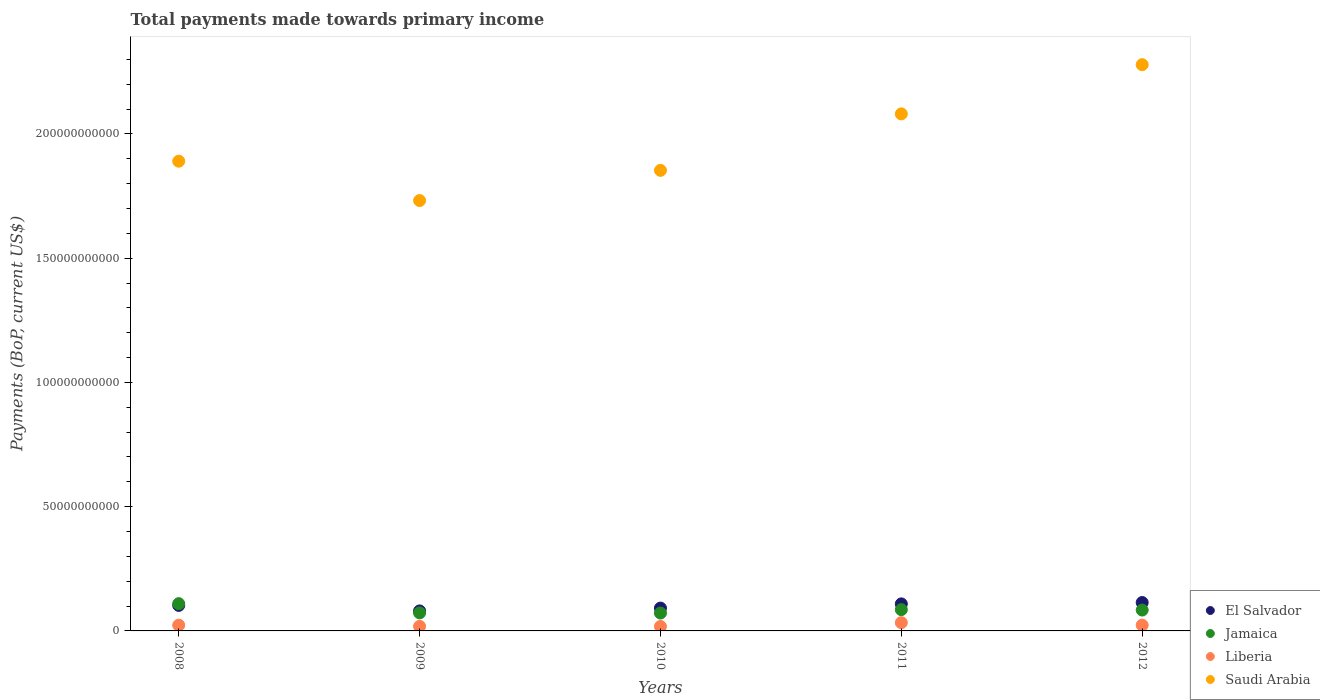What is the total payments made towards primary income in Liberia in 2008?
Ensure brevity in your answer.  2.31e+09. Across all years, what is the maximum total payments made towards primary income in Liberia?
Offer a terse response. 3.33e+09. Across all years, what is the minimum total payments made towards primary income in Saudi Arabia?
Offer a terse response. 1.73e+11. In which year was the total payments made towards primary income in Liberia maximum?
Ensure brevity in your answer.  2011. In which year was the total payments made towards primary income in Jamaica minimum?
Offer a terse response. 2010. What is the total total payments made towards primary income in Saudi Arabia in the graph?
Your response must be concise. 9.83e+11. What is the difference between the total payments made towards primary income in Liberia in 2010 and that in 2011?
Provide a short and direct response. -1.52e+09. What is the difference between the total payments made towards primary income in Jamaica in 2008 and the total payments made towards primary income in El Salvador in 2012?
Provide a short and direct response. -4.55e+08. What is the average total payments made towards primary income in Saudi Arabia per year?
Provide a short and direct response. 1.97e+11. In the year 2009, what is the difference between the total payments made towards primary income in Saudi Arabia and total payments made towards primary income in Liberia?
Give a very brief answer. 1.71e+11. In how many years, is the total payments made towards primary income in Liberia greater than 90000000000 US$?
Keep it short and to the point. 0. What is the ratio of the total payments made towards primary income in Saudi Arabia in 2009 to that in 2010?
Provide a short and direct response. 0.93. Is the difference between the total payments made towards primary income in Saudi Arabia in 2008 and 2010 greater than the difference between the total payments made towards primary income in Liberia in 2008 and 2010?
Your answer should be very brief. Yes. What is the difference between the highest and the second highest total payments made towards primary income in Saudi Arabia?
Provide a short and direct response. 1.98e+1. What is the difference between the highest and the lowest total payments made towards primary income in El Salvador?
Your answer should be very brief. 3.38e+09. Is it the case that in every year, the sum of the total payments made towards primary income in Liberia and total payments made towards primary income in El Salvador  is greater than the total payments made towards primary income in Jamaica?
Ensure brevity in your answer.  Yes. Is the total payments made towards primary income in Liberia strictly greater than the total payments made towards primary income in Jamaica over the years?
Your response must be concise. No. What is the difference between two consecutive major ticks on the Y-axis?
Ensure brevity in your answer.  5.00e+1. Are the values on the major ticks of Y-axis written in scientific E-notation?
Your response must be concise. No. How are the legend labels stacked?
Offer a very short reply. Vertical. What is the title of the graph?
Ensure brevity in your answer.  Total payments made towards primary income. Does "Congo (Republic)" appear as one of the legend labels in the graph?
Give a very brief answer. No. What is the label or title of the Y-axis?
Your answer should be very brief. Payments (BoP, current US$). What is the Payments (BoP, current US$) of El Salvador in 2008?
Offer a very short reply. 1.03e+1. What is the Payments (BoP, current US$) of Jamaica in 2008?
Provide a short and direct response. 1.10e+1. What is the Payments (BoP, current US$) of Liberia in 2008?
Give a very brief answer. 2.31e+09. What is the Payments (BoP, current US$) in Saudi Arabia in 2008?
Provide a succinct answer. 1.89e+11. What is the Payments (BoP, current US$) of El Salvador in 2009?
Provide a short and direct response. 8.05e+09. What is the Payments (BoP, current US$) of Jamaica in 2009?
Provide a succinct answer. 7.26e+09. What is the Payments (BoP, current US$) in Liberia in 2009?
Keep it short and to the point. 1.85e+09. What is the Payments (BoP, current US$) of Saudi Arabia in 2009?
Provide a short and direct response. 1.73e+11. What is the Payments (BoP, current US$) in El Salvador in 2010?
Make the answer very short. 9.19e+09. What is the Payments (BoP, current US$) in Jamaica in 2010?
Make the answer very short. 7.19e+09. What is the Payments (BoP, current US$) of Liberia in 2010?
Offer a terse response. 1.80e+09. What is the Payments (BoP, current US$) of Saudi Arabia in 2010?
Make the answer very short. 1.85e+11. What is the Payments (BoP, current US$) of El Salvador in 2011?
Your response must be concise. 1.09e+1. What is the Payments (BoP, current US$) of Jamaica in 2011?
Ensure brevity in your answer.  8.57e+09. What is the Payments (BoP, current US$) of Liberia in 2011?
Your response must be concise. 3.33e+09. What is the Payments (BoP, current US$) of Saudi Arabia in 2011?
Offer a terse response. 2.08e+11. What is the Payments (BoP, current US$) in El Salvador in 2012?
Your answer should be very brief. 1.14e+1. What is the Payments (BoP, current US$) of Jamaica in 2012?
Offer a very short reply. 8.40e+09. What is the Payments (BoP, current US$) in Liberia in 2012?
Offer a very short reply. 2.32e+09. What is the Payments (BoP, current US$) in Saudi Arabia in 2012?
Provide a short and direct response. 2.28e+11. Across all years, what is the maximum Payments (BoP, current US$) of El Salvador?
Your response must be concise. 1.14e+1. Across all years, what is the maximum Payments (BoP, current US$) in Jamaica?
Your answer should be compact. 1.10e+1. Across all years, what is the maximum Payments (BoP, current US$) of Liberia?
Provide a succinct answer. 3.33e+09. Across all years, what is the maximum Payments (BoP, current US$) of Saudi Arabia?
Make the answer very short. 2.28e+11. Across all years, what is the minimum Payments (BoP, current US$) in El Salvador?
Make the answer very short. 8.05e+09. Across all years, what is the minimum Payments (BoP, current US$) in Jamaica?
Make the answer very short. 7.19e+09. Across all years, what is the minimum Payments (BoP, current US$) in Liberia?
Your response must be concise. 1.80e+09. Across all years, what is the minimum Payments (BoP, current US$) of Saudi Arabia?
Offer a very short reply. 1.73e+11. What is the total Payments (BoP, current US$) in El Salvador in the graph?
Provide a short and direct response. 4.98e+1. What is the total Payments (BoP, current US$) in Jamaica in the graph?
Keep it short and to the point. 4.24e+1. What is the total Payments (BoP, current US$) in Liberia in the graph?
Provide a succinct answer. 1.16e+1. What is the total Payments (BoP, current US$) of Saudi Arabia in the graph?
Provide a short and direct response. 9.83e+11. What is the difference between the Payments (BoP, current US$) in El Salvador in 2008 and that in 2009?
Offer a very short reply. 2.22e+09. What is the difference between the Payments (BoP, current US$) in Jamaica in 2008 and that in 2009?
Keep it short and to the point. 3.71e+09. What is the difference between the Payments (BoP, current US$) in Liberia in 2008 and that in 2009?
Keep it short and to the point. 4.61e+08. What is the difference between the Payments (BoP, current US$) in Saudi Arabia in 2008 and that in 2009?
Offer a very short reply. 1.58e+1. What is the difference between the Payments (BoP, current US$) in El Salvador in 2008 and that in 2010?
Your answer should be very brief. 1.08e+09. What is the difference between the Payments (BoP, current US$) of Jamaica in 2008 and that in 2010?
Make the answer very short. 3.78e+09. What is the difference between the Payments (BoP, current US$) of Liberia in 2008 and that in 2010?
Provide a short and direct response. 5.06e+08. What is the difference between the Payments (BoP, current US$) of Saudi Arabia in 2008 and that in 2010?
Your answer should be compact. 3.69e+09. What is the difference between the Payments (BoP, current US$) in El Salvador in 2008 and that in 2011?
Give a very brief answer. -6.14e+08. What is the difference between the Payments (BoP, current US$) of Jamaica in 2008 and that in 2011?
Offer a terse response. 2.40e+09. What is the difference between the Payments (BoP, current US$) of Liberia in 2008 and that in 2011?
Your answer should be very brief. -1.01e+09. What is the difference between the Payments (BoP, current US$) in Saudi Arabia in 2008 and that in 2011?
Provide a short and direct response. -1.90e+1. What is the difference between the Payments (BoP, current US$) in El Salvador in 2008 and that in 2012?
Ensure brevity in your answer.  -1.16e+09. What is the difference between the Payments (BoP, current US$) in Jamaica in 2008 and that in 2012?
Ensure brevity in your answer.  2.57e+09. What is the difference between the Payments (BoP, current US$) in Liberia in 2008 and that in 2012?
Provide a short and direct response. -6.47e+06. What is the difference between the Payments (BoP, current US$) in Saudi Arabia in 2008 and that in 2012?
Make the answer very short. -3.88e+1. What is the difference between the Payments (BoP, current US$) of El Salvador in 2009 and that in 2010?
Your answer should be compact. -1.14e+09. What is the difference between the Payments (BoP, current US$) in Jamaica in 2009 and that in 2010?
Give a very brief answer. 6.76e+07. What is the difference between the Payments (BoP, current US$) in Liberia in 2009 and that in 2010?
Ensure brevity in your answer.  4.54e+07. What is the difference between the Payments (BoP, current US$) in Saudi Arabia in 2009 and that in 2010?
Provide a short and direct response. -1.21e+1. What is the difference between the Payments (BoP, current US$) in El Salvador in 2009 and that in 2011?
Give a very brief answer. -2.83e+09. What is the difference between the Payments (BoP, current US$) of Jamaica in 2009 and that in 2011?
Your answer should be compact. -1.31e+09. What is the difference between the Payments (BoP, current US$) of Liberia in 2009 and that in 2011?
Your answer should be very brief. -1.48e+09. What is the difference between the Payments (BoP, current US$) of Saudi Arabia in 2009 and that in 2011?
Your answer should be compact. -3.49e+1. What is the difference between the Payments (BoP, current US$) of El Salvador in 2009 and that in 2012?
Offer a very short reply. -3.38e+09. What is the difference between the Payments (BoP, current US$) in Jamaica in 2009 and that in 2012?
Make the answer very short. -1.14e+09. What is the difference between the Payments (BoP, current US$) in Liberia in 2009 and that in 2012?
Provide a succinct answer. -4.67e+08. What is the difference between the Payments (BoP, current US$) of Saudi Arabia in 2009 and that in 2012?
Offer a very short reply. -5.47e+1. What is the difference between the Payments (BoP, current US$) in El Salvador in 2010 and that in 2011?
Ensure brevity in your answer.  -1.69e+09. What is the difference between the Payments (BoP, current US$) in Jamaica in 2010 and that in 2011?
Your answer should be compact. -1.38e+09. What is the difference between the Payments (BoP, current US$) of Liberia in 2010 and that in 2011?
Make the answer very short. -1.52e+09. What is the difference between the Payments (BoP, current US$) in Saudi Arabia in 2010 and that in 2011?
Give a very brief answer. -2.27e+1. What is the difference between the Payments (BoP, current US$) in El Salvador in 2010 and that in 2012?
Provide a succinct answer. -2.24e+09. What is the difference between the Payments (BoP, current US$) in Jamaica in 2010 and that in 2012?
Ensure brevity in your answer.  -1.20e+09. What is the difference between the Payments (BoP, current US$) in Liberia in 2010 and that in 2012?
Offer a terse response. -5.12e+08. What is the difference between the Payments (BoP, current US$) of Saudi Arabia in 2010 and that in 2012?
Offer a terse response. -4.25e+1. What is the difference between the Payments (BoP, current US$) of El Salvador in 2011 and that in 2012?
Keep it short and to the point. -5.44e+08. What is the difference between the Payments (BoP, current US$) of Jamaica in 2011 and that in 2012?
Your answer should be compact. 1.71e+08. What is the difference between the Payments (BoP, current US$) in Liberia in 2011 and that in 2012?
Give a very brief answer. 1.01e+09. What is the difference between the Payments (BoP, current US$) in Saudi Arabia in 2011 and that in 2012?
Make the answer very short. -1.98e+1. What is the difference between the Payments (BoP, current US$) of El Salvador in 2008 and the Payments (BoP, current US$) of Jamaica in 2009?
Your answer should be compact. 3.01e+09. What is the difference between the Payments (BoP, current US$) of El Salvador in 2008 and the Payments (BoP, current US$) of Liberia in 2009?
Offer a very short reply. 8.42e+09. What is the difference between the Payments (BoP, current US$) of El Salvador in 2008 and the Payments (BoP, current US$) of Saudi Arabia in 2009?
Your answer should be compact. -1.63e+11. What is the difference between the Payments (BoP, current US$) in Jamaica in 2008 and the Payments (BoP, current US$) in Liberia in 2009?
Offer a terse response. 9.12e+09. What is the difference between the Payments (BoP, current US$) in Jamaica in 2008 and the Payments (BoP, current US$) in Saudi Arabia in 2009?
Provide a succinct answer. -1.62e+11. What is the difference between the Payments (BoP, current US$) in Liberia in 2008 and the Payments (BoP, current US$) in Saudi Arabia in 2009?
Provide a short and direct response. -1.71e+11. What is the difference between the Payments (BoP, current US$) in El Salvador in 2008 and the Payments (BoP, current US$) in Jamaica in 2010?
Provide a short and direct response. 3.08e+09. What is the difference between the Payments (BoP, current US$) of El Salvador in 2008 and the Payments (BoP, current US$) of Liberia in 2010?
Offer a very short reply. 8.46e+09. What is the difference between the Payments (BoP, current US$) of El Salvador in 2008 and the Payments (BoP, current US$) of Saudi Arabia in 2010?
Keep it short and to the point. -1.75e+11. What is the difference between the Payments (BoP, current US$) of Jamaica in 2008 and the Payments (BoP, current US$) of Liberia in 2010?
Offer a terse response. 9.17e+09. What is the difference between the Payments (BoP, current US$) of Jamaica in 2008 and the Payments (BoP, current US$) of Saudi Arabia in 2010?
Your answer should be compact. -1.74e+11. What is the difference between the Payments (BoP, current US$) of Liberia in 2008 and the Payments (BoP, current US$) of Saudi Arabia in 2010?
Provide a succinct answer. -1.83e+11. What is the difference between the Payments (BoP, current US$) in El Salvador in 2008 and the Payments (BoP, current US$) in Jamaica in 2011?
Offer a very short reply. 1.70e+09. What is the difference between the Payments (BoP, current US$) in El Salvador in 2008 and the Payments (BoP, current US$) in Liberia in 2011?
Your response must be concise. 6.94e+09. What is the difference between the Payments (BoP, current US$) of El Salvador in 2008 and the Payments (BoP, current US$) of Saudi Arabia in 2011?
Keep it short and to the point. -1.98e+11. What is the difference between the Payments (BoP, current US$) of Jamaica in 2008 and the Payments (BoP, current US$) of Liberia in 2011?
Keep it short and to the point. 7.64e+09. What is the difference between the Payments (BoP, current US$) of Jamaica in 2008 and the Payments (BoP, current US$) of Saudi Arabia in 2011?
Ensure brevity in your answer.  -1.97e+11. What is the difference between the Payments (BoP, current US$) of Liberia in 2008 and the Payments (BoP, current US$) of Saudi Arabia in 2011?
Make the answer very short. -2.06e+11. What is the difference between the Payments (BoP, current US$) of El Salvador in 2008 and the Payments (BoP, current US$) of Jamaica in 2012?
Provide a succinct answer. 1.87e+09. What is the difference between the Payments (BoP, current US$) of El Salvador in 2008 and the Payments (BoP, current US$) of Liberia in 2012?
Make the answer very short. 7.95e+09. What is the difference between the Payments (BoP, current US$) in El Salvador in 2008 and the Payments (BoP, current US$) in Saudi Arabia in 2012?
Offer a very short reply. -2.18e+11. What is the difference between the Payments (BoP, current US$) in Jamaica in 2008 and the Payments (BoP, current US$) in Liberia in 2012?
Make the answer very short. 8.65e+09. What is the difference between the Payments (BoP, current US$) in Jamaica in 2008 and the Payments (BoP, current US$) in Saudi Arabia in 2012?
Provide a succinct answer. -2.17e+11. What is the difference between the Payments (BoP, current US$) in Liberia in 2008 and the Payments (BoP, current US$) in Saudi Arabia in 2012?
Offer a very short reply. -2.26e+11. What is the difference between the Payments (BoP, current US$) of El Salvador in 2009 and the Payments (BoP, current US$) of Jamaica in 2010?
Offer a terse response. 8.55e+08. What is the difference between the Payments (BoP, current US$) of El Salvador in 2009 and the Payments (BoP, current US$) of Liberia in 2010?
Ensure brevity in your answer.  6.24e+09. What is the difference between the Payments (BoP, current US$) in El Salvador in 2009 and the Payments (BoP, current US$) in Saudi Arabia in 2010?
Make the answer very short. -1.77e+11. What is the difference between the Payments (BoP, current US$) in Jamaica in 2009 and the Payments (BoP, current US$) in Liberia in 2010?
Your response must be concise. 5.45e+09. What is the difference between the Payments (BoP, current US$) of Jamaica in 2009 and the Payments (BoP, current US$) of Saudi Arabia in 2010?
Offer a very short reply. -1.78e+11. What is the difference between the Payments (BoP, current US$) of Liberia in 2009 and the Payments (BoP, current US$) of Saudi Arabia in 2010?
Offer a terse response. -1.83e+11. What is the difference between the Payments (BoP, current US$) in El Salvador in 2009 and the Payments (BoP, current US$) in Jamaica in 2011?
Your answer should be compact. -5.21e+08. What is the difference between the Payments (BoP, current US$) of El Salvador in 2009 and the Payments (BoP, current US$) of Liberia in 2011?
Provide a succinct answer. 4.72e+09. What is the difference between the Payments (BoP, current US$) in El Salvador in 2009 and the Payments (BoP, current US$) in Saudi Arabia in 2011?
Make the answer very short. -2.00e+11. What is the difference between the Payments (BoP, current US$) of Jamaica in 2009 and the Payments (BoP, current US$) of Liberia in 2011?
Your answer should be very brief. 3.93e+09. What is the difference between the Payments (BoP, current US$) in Jamaica in 2009 and the Payments (BoP, current US$) in Saudi Arabia in 2011?
Your answer should be compact. -2.01e+11. What is the difference between the Payments (BoP, current US$) in Liberia in 2009 and the Payments (BoP, current US$) in Saudi Arabia in 2011?
Keep it short and to the point. -2.06e+11. What is the difference between the Payments (BoP, current US$) in El Salvador in 2009 and the Payments (BoP, current US$) in Jamaica in 2012?
Your answer should be compact. -3.49e+08. What is the difference between the Payments (BoP, current US$) in El Salvador in 2009 and the Payments (BoP, current US$) in Liberia in 2012?
Your response must be concise. 5.73e+09. What is the difference between the Payments (BoP, current US$) of El Salvador in 2009 and the Payments (BoP, current US$) of Saudi Arabia in 2012?
Provide a succinct answer. -2.20e+11. What is the difference between the Payments (BoP, current US$) of Jamaica in 2009 and the Payments (BoP, current US$) of Liberia in 2012?
Keep it short and to the point. 4.94e+09. What is the difference between the Payments (BoP, current US$) of Jamaica in 2009 and the Payments (BoP, current US$) of Saudi Arabia in 2012?
Keep it short and to the point. -2.21e+11. What is the difference between the Payments (BoP, current US$) in Liberia in 2009 and the Payments (BoP, current US$) in Saudi Arabia in 2012?
Your response must be concise. -2.26e+11. What is the difference between the Payments (BoP, current US$) in El Salvador in 2010 and the Payments (BoP, current US$) in Jamaica in 2011?
Your answer should be compact. 6.22e+08. What is the difference between the Payments (BoP, current US$) in El Salvador in 2010 and the Payments (BoP, current US$) in Liberia in 2011?
Your answer should be compact. 5.86e+09. What is the difference between the Payments (BoP, current US$) in El Salvador in 2010 and the Payments (BoP, current US$) in Saudi Arabia in 2011?
Offer a very short reply. -1.99e+11. What is the difference between the Payments (BoP, current US$) of Jamaica in 2010 and the Payments (BoP, current US$) of Liberia in 2011?
Your answer should be very brief. 3.87e+09. What is the difference between the Payments (BoP, current US$) of Jamaica in 2010 and the Payments (BoP, current US$) of Saudi Arabia in 2011?
Give a very brief answer. -2.01e+11. What is the difference between the Payments (BoP, current US$) in Liberia in 2010 and the Payments (BoP, current US$) in Saudi Arabia in 2011?
Offer a very short reply. -2.06e+11. What is the difference between the Payments (BoP, current US$) in El Salvador in 2010 and the Payments (BoP, current US$) in Jamaica in 2012?
Your answer should be very brief. 7.94e+08. What is the difference between the Payments (BoP, current US$) in El Salvador in 2010 and the Payments (BoP, current US$) in Liberia in 2012?
Make the answer very short. 6.87e+09. What is the difference between the Payments (BoP, current US$) in El Salvador in 2010 and the Payments (BoP, current US$) in Saudi Arabia in 2012?
Provide a short and direct response. -2.19e+11. What is the difference between the Payments (BoP, current US$) in Jamaica in 2010 and the Payments (BoP, current US$) in Liberia in 2012?
Offer a very short reply. 4.87e+09. What is the difference between the Payments (BoP, current US$) of Jamaica in 2010 and the Payments (BoP, current US$) of Saudi Arabia in 2012?
Make the answer very short. -2.21e+11. What is the difference between the Payments (BoP, current US$) in Liberia in 2010 and the Payments (BoP, current US$) in Saudi Arabia in 2012?
Make the answer very short. -2.26e+11. What is the difference between the Payments (BoP, current US$) in El Salvador in 2011 and the Payments (BoP, current US$) in Jamaica in 2012?
Your answer should be compact. 2.49e+09. What is the difference between the Payments (BoP, current US$) of El Salvador in 2011 and the Payments (BoP, current US$) of Liberia in 2012?
Ensure brevity in your answer.  8.56e+09. What is the difference between the Payments (BoP, current US$) in El Salvador in 2011 and the Payments (BoP, current US$) in Saudi Arabia in 2012?
Offer a very short reply. -2.17e+11. What is the difference between the Payments (BoP, current US$) in Jamaica in 2011 and the Payments (BoP, current US$) in Liberia in 2012?
Keep it short and to the point. 6.25e+09. What is the difference between the Payments (BoP, current US$) of Jamaica in 2011 and the Payments (BoP, current US$) of Saudi Arabia in 2012?
Provide a short and direct response. -2.19e+11. What is the difference between the Payments (BoP, current US$) in Liberia in 2011 and the Payments (BoP, current US$) in Saudi Arabia in 2012?
Provide a short and direct response. -2.25e+11. What is the average Payments (BoP, current US$) of El Salvador per year?
Your answer should be very brief. 9.96e+09. What is the average Payments (BoP, current US$) in Jamaica per year?
Ensure brevity in your answer.  8.48e+09. What is the average Payments (BoP, current US$) in Liberia per year?
Give a very brief answer. 2.32e+09. What is the average Payments (BoP, current US$) in Saudi Arabia per year?
Offer a terse response. 1.97e+11. In the year 2008, what is the difference between the Payments (BoP, current US$) of El Salvador and Payments (BoP, current US$) of Jamaica?
Offer a terse response. -7.02e+08. In the year 2008, what is the difference between the Payments (BoP, current US$) in El Salvador and Payments (BoP, current US$) in Liberia?
Your answer should be very brief. 7.96e+09. In the year 2008, what is the difference between the Payments (BoP, current US$) in El Salvador and Payments (BoP, current US$) in Saudi Arabia?
Your answer should be very brief. -1.79e+11. In the year 2008, what is the difference between the Payments (BoP, current US$) in Jamaica and Payments (BoP, current US$) in Liberia?
Your response must be concise. 8.66e+09. In the year 2008, what is the difference between the Payments (BoP, current US$) of Jamaica and Payments (BoP, current US$) of Saudi Arabia?
Provide a short and direct response. -1.78e+11. In the year 2008, what is the difference between the Payments (BoP, current US$) in Liberia and Payments (BoP, current US$) in Saudi Arabia?
Provide a short and direct response. -1.87e+11. In the year 2009, what is the difference between the Payments (BoP, current US$) in El Salvador and Payments (BoP, current US$) in Jamaica?
Make the answer very short. 7.88e+08. In the year 2009, what is the difference between the Payments (BoP, current US$) in El Salvador and Payments (BoP, current US$) in Liberia?
Your response must be concise. 6.20e+09. In the year 2009, what is the difference between the Payments (BoP, current US$) of El Salvador and Payments (BoP, current US$) of Saudi Arabia?
Your response must be concise. -1.65e+11. In the year 2009, what is the difference between the Payments (BoP, current US$) in Jamaica and Payments (BoP, current US$) in Liberia?
Give a very brief answer. 5.41e+09. In the year 2009, what is the difference between the Payments (BoP, current US$) in Jamaica and Payments (BoP, current US$) in Saudi Arabia?
Make the answer very short. -1.66e+11. In the year 2009, what is the difference between the Payments (BoP, current US$) in Liberia and Payments (BoP, current US$) in Saudi Arabia?
Your response must be concise. -1.71e+11. In the year 2010, what is the difference between the Payments (BoP, current US$) in El Salvador and Payments (BoP, current US$) in Jamaica?
Provide a short and direct response. 2.00e+09. In the year 2010, what is the difference between the Payments (BoP, current US$) of El Salvador and Payments (BoP, current US$) of Liberia?
Your answer should be compact. 7.39e+09. In the year 2010, what is the difference between the Payments (BoP, current US$) in El Salvador and Payments (BoP, current US$) in Saudi Arabia?
Your answer should be very brief. -1.76e+11. In the year 2010, what is the difference between the Payments (BoP, current US$) in Jamaica and Payments (BoP, current US$) in Liberia?
Ensure brevity in your answer.  5.39e+09. In the year 2010, what is the difference between the Payments (BoP, current US$) in Jamaica and Payments (BoP, current US$) in Saudi Arabia?
Give a very brief answer. -1.78e+11. In the year 2010, what is the difference between the Payments (BoP, current US$) in Liberia and Payments (BoP, current US$) in Saudi Arabia?
Give a very brief answer. -1.84e+11. In the year 2011, what is the difference between the Payments (BoP, current US$) in El Salvador and Payments (BoP, current US$) in Jamaica?
Your answer should be compact. 2.31e+09. In the year 2011, what is the difference between the Payments (BoP, current US$) of El Salvador and Payments (BoP, current US$) of Liberia?
Offer a terse response. 7.56e+09. In the year 2011, what is the difference between the Payments (BoP, current US$) of El Salvador and Payments (BoP, current US$) of Saudi Arabia?
Offer a terse response. -1.97e+11. In the year 2011, what is the difference between the Payments (BoP, current US$) in Jamaica and Payments (BoP, current US$) in Liberia?
Offer a very short reply. 5.24e+09. In the year 2011, what is the difference between the Payments (BoP, current US$) in Jamaica and Payments (BoP, current US$) in Saudi Arabia?
Offer a terse response. -1.99e+11. In the year 2011, what is the difference between the Payments (BoP, current US$) of Liberia and Payments (BoP, current US$) of Saudi Arabia?
Provide a succinct answer. -2.05e+11. In the year 2012, what is the difference between the Payments (BoP, current US$) of El Salvador and Payments (BoP, current US$) of Jamaica?
Keep it short and to the point. 3.03e+09. In the year 2012, what is the difference between the Payments (BoP, current US$) of El Salvador and Payments (BoP, current US$) of Liberia?
Your response must be concise. 9.11e+09. In the year 2012, what is the difference between the Payments (BoP, current US$) of El Salvador and Payments (BoP, current US$) of Saudi Arabia?
Keep it short and to the point. -2.16e+11. In the year 2012, what is the difference between the Payments (BoP, current US$) in Jamaica and Payments (BoP, current US$) in Liberia?
Provide a succinct answer. 6.08e+09. In the year 2012, what is the difference between the Payments (BoP, current US$) in Jamaica and Payments (BoP, current US$) in Saudi Arabia?
Your answer should be compact. -2.19e+11. In the year 2012, what is the difference between the Payments (BoP, current US$) in Liberia and Payments (BoP, current US$) in Saudi Arabia?
Offer a very short reply. -2.26e+11. What is the ratio of the Payments (BoP, current US$) in El Salvador in 2008 to that in 2009?
Ensure brevity in your answer.  1.28. What is the ratio of the Payments (BoP, current US$) in Jamaica in 2008 to that in 2009?
Your answer should be compact. 1.51. What is the ratio of the Payments (BoP, current US$) in Liberia in 2008 to that in 2009?
Offer a terse response. 1.25. What is the ratio of the Payments (BoP, current US$) in Saudi Arabia in 2008 to that in 2009?
Give a very brief answer. 1.09. What is the ratio of the Payments (BoP, current US$) of El Salvador in 2008 to that in 2010?
Your answer should be very brief. 1.12. What is the ratio of the Payments (BoP, current US$) of Jamaica in 2008 to that in 2010?
Offer a terse response. 1.53. What is the ratio of the Payments (BoP, current US$) of Liberia in 2008 to that in 2010?
Keep it short and to the point. 1.28. What is the ratio of the Payments (BoP, current US$) of Saudi Arabia in 2008 to that in 2010?
Your answer should be very brief. 1.02. What is the ratio of the Payments (BoP, current US$) in El Salvador in 2008 to that in 2011?
Give a very brief answer. 0.94. What is the ratio of the Payments (BoP, current US$) of Jamaica in 2008 to that in 2011?
Provide a short and direct response. 1.28. What is the ratio of the Payments (BoP, current US$) of Liberia in 2008 to that in 2011?
Your answer should be very brief. 0.69. What is the ratio of the Payments (BoP, current US$) in Saudi Arabia in 2008 to that in 2011?
Offer a very short reply. 0.91. What is the ratio of the Payments (BoP, current US$) of El Salvador in 2008 to that in 2012?
Provide a short and direct response. 0.9. What is the ratio of the Payments (BoP, current US$) of Jamaica in 2008 to that in 2012?
Offer a very short reply. 1.31. What is the ratio of the Payments (BoP, current US$) in Saudi Arabia in 2008 to that in 2012?
Keep it short and to the point. 0.83. What is the ratio of the Payments (BoP, current US$) in El Salvador in 2009 to that in 2010?
Offer a terse response. 0.88. What is the ratio of the Payments (BoP, current US$) in Jamaica in 2009 to that in 2010?
Provide a short and direct response. 1.01. What is the ratio of the Payments (BoP, current US$) in Liberia in 2009 to that in 2010?
Make the answer very short. 1.03. What is the ratio of the Payments (BoP, current US$) in Saudi Arabia in 2009 to that in 2010?
Your response must be concise. 0.93. What is the ratio of the Payments (BoP, current US$) of El Salvador in 2009 to that in 2011?
Your answer should be compact. 0.74. What is the ratio of the Payments (BoP, current US$) in Jamaica in 2009 to that in 2011?
Offer a very short reply. 0.85. What is the ratio of the Payments (BoP, current US$) in Liberia in 2009 to that in 2011?
Offer a very short reply. 0.56. What is the ratio of the Payments (BoP, current US$) of Saudi Arabia in 2009 to that in 2011?
Provide a short and direct response. 0.83. What is the ratio of the Payments (BoP, current US$) in El Salvador in 2009 to that in 2012?
Your answer should be very brief. 0.7. What is the ratio of the Payments (BoP, current US$) in Jamaica in 2009 to that in 2012?
Provide a succinct answer. 0.86. What is the ratio of the Payments (BoP, current US$) of Liberia in 2009 to that in 2012?
Your answer should be compact. 0.8. What is the ratio of the Payments (BoP, current US$) in Saudi Arabia in 2009 to that in 2012?
Your answer should be compact. 0.76. What is the ratio of the Payments (BoP, current US$) of El Salvador in 2010 to that in 2011?
Provide a succinct answer. 0.84. What is the ratio of the Payments (BoP, current US$) in Jamaica in 2010 to that in 2011?
Provide a short and direct response. 0.84. What is the ratio of the Payments (BoP, current US$) in Liberia in 2010 to that in 2011?
Your answer should be very brief. 0.54. What is the ratio of the Payments (BoP, current US$) in Saudi Arabia in 2010 to that in 2011?
Provide a succinct answer. 0.89. What is the ratio of the Payments (BoP, current US$) of El Salvador in 2010 to that in 2012?
Provide a succinct answer. 0.8. What is the ratio of the Payments (BoP, current US$) of Jamaica in 2010 to that in 2012?
Offer a very short reply. 0.86. What is the ratio of the Payments (BoP, current US$) in Liberia in 2010 to that in 2012?
Make the answer very short. 0.78. What is the ratio of the Payments (BoP, current US$) of Saudi Arabia in 2010 to that in 2012?
Give a very brief answer. 0.81. What is the ratio of the Payments (BoP, current US$) of Jamaica in 2011 to that in 2012?
Your answer should be very brief. 1.02. What is the ratio of the Payments (BoP, current US$) in Liberia in 2011 to that in 2012?
Your response must be concise. 1.44. What is the ratio of the Payments (BoP, current US$) in Saudi Arabia in 2011 to that in 2012?
Your answer should be very brief. 0.91. What is the difference between the highest and the second highest Payments (BoP, current US$) of El Salvador?
Make the answer very short. 5.44e+08. What is the difference between the highest and the second highest Payments (BoP, current US$) in Jamaica?
Offer a very short reply. 2.40e+09. What is the difference between the highest and the second highest Payments (BoP, current US$) of Liberia?
Your answer should be very brief. 1.01e+09. What is the difference between the highest and the second highest Payments (BoP, current US$) in Saudi Arabia?
Your response must be concise. 1.98e+1. What is the difference between the highest and the lowest Payments (BoP, current US$) of El Salvador?
Your answer should be very brief. 3.38e+09. What is the difference between the highest and the lowest Payments (BoP, current US$) in Jamaica?
Your response must be concise. 3.78e+09. What is the difference between the highest and the lowest Payments (BoP, current US$) of Liberia?
Provide a short and direct response. 1.52e+09. What is the difference between the highest and the lowest Payments (BoP, current US$) in Saudi Arabia?
Offer a very short reply. 5.47e+1. 